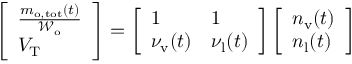Convert formula to latex. <formula><loc_0><loc_0><loc_500><loc_500>\begin{array} { r } { \left [ \begin{array} { l } { \frac { m _ { o , t o t } ( t ) } { \mathcal { W } _ { o } } } \\ { V _ { T } } \end{array} \right ] = \left [ \begin{array} { l l } { 1 } & { 1 } \\ { \nu _ { v } ( t ) } & { \nu _ { l } ( t ) } \end{array} \right ] \left [ \begin{array} { l } { n _ { v } ( t ) } \\ { n _ { l } ( t ) } \end{array} \right ] } \end{array}</formula> 